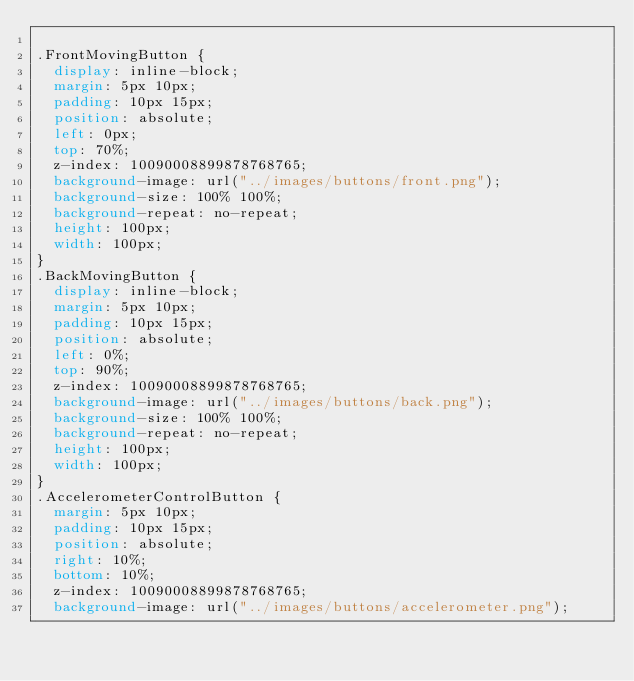<code> <loc_0><loc_0><loc_500><loc_500><_CSS_>
.FrontMovingButton {
	display: inline-block;
	margin: 5px 10px;
	padding: 10px 15px;
	position: absolute;
	left: 0px;
	top: 70%;
	z-index: 10090008899878768765;
	background-image: url("../images/buttons/front.png");
	background-size: 100% 100%;
	background-repeat: no-repeat;
	height: 100px;
	width: 100px;
}
.BackMovingButton {
	display: inline-block;
	margin: 5px 10px;
	padding: 10px 15px;
	position: absolute;
	left: 0%;
	top: 90%;
	z-index: 10090008899878768765;
	background-image: url("../images/buttons/back.png");
	background-size: 100% 100%;
	background-repeat: no-repeat;
	height: 100px;
	width: 100px;
}
.AccelerometerControlButton {
	margin: 5px 10px;
	padding: 10px 15px;
	position: absolute;
	right: 10%;
	bottom: 10%;
	z-index: 10090008899878768765;
	background-image: url("../images/buttons/accelerometer.png");</code> 